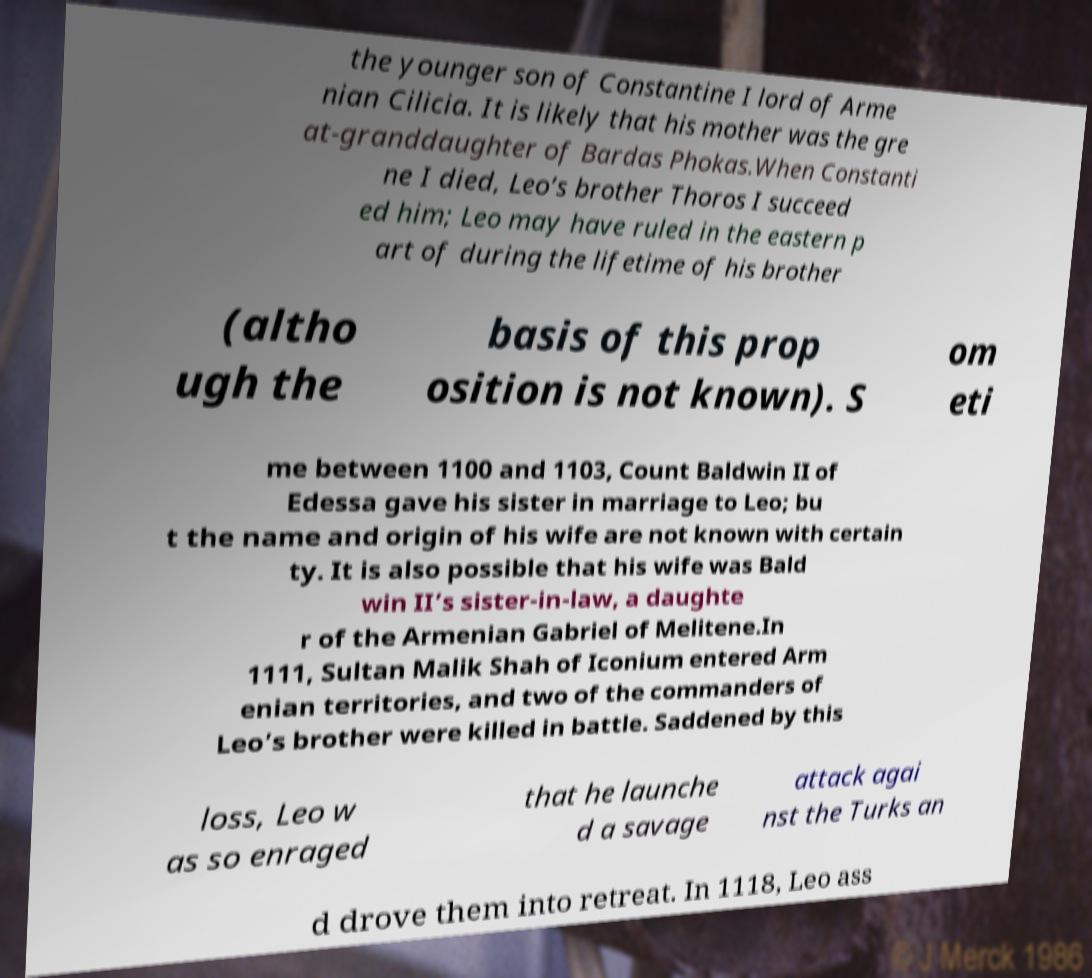There's text embedded in this image that I need extracted. Can you transcribe it verbatim? the younger son of Constantine I lord of Arme nian Cilicia. It is likely that his mother was the gre at-granddaughter of Bardas Phokas.When Constanti ne I died, Leo’s brother Thoros I succeed ed him; Leo may have ruled in the eastern p art of during the lifetime of his brother (altho ugh the basis of this prop osition is not known). S om eti me between 1100 and 1103, Count Baldwin II of Edessa gave his sister in marriage to Leo; bu t the name and origin of his wife are not known with certain ty. It is also possible that his wife was Bald win II’s sister-in-law, a daughte r of the Armenian Gabriel of Melitene.In 1111, Sultan Malik Shah of Iconium entered Arm enian territories, and two of the commanders of Leo’s brother were killed in battle. Saddened by this loss, Leo w as so enraged that he launche d a savage attack agai nst the Turks an d drove them into retreat. In 1118, Leo ass 